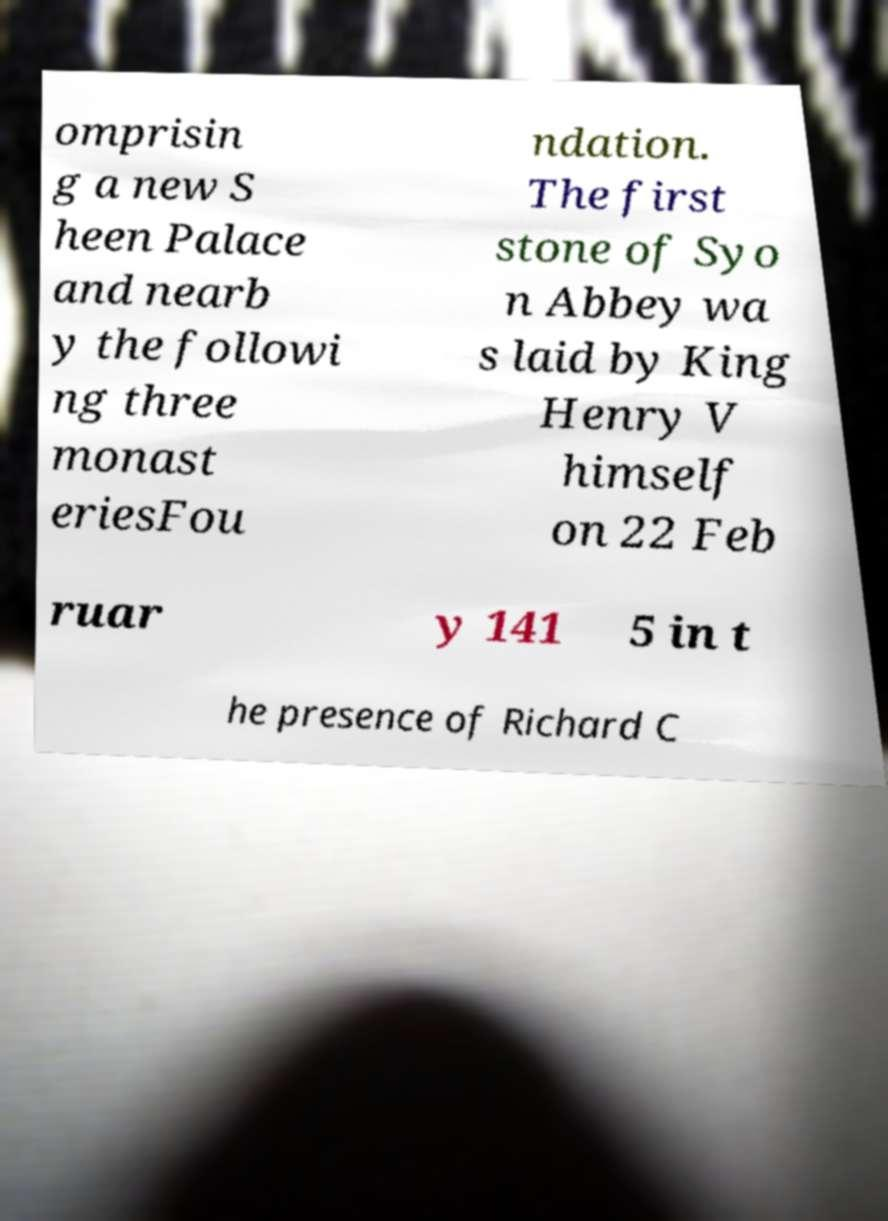Could you assist in decoding the text presented in this image and type it out clearly? omprisin g a new S heen Palace and nearb y the followi ng three monast eriesFou ndation. The first stone of Syo n Abbey wa s laid by King Henry V himself on 22 Feb ruar y 141 5 in t he presence of Richard C 